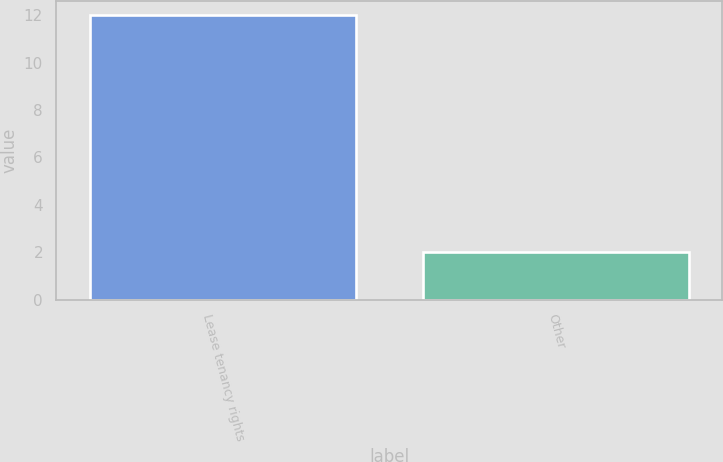Convert chart. <chart><loc_0><loc_0><loc_500><loc_500><bar_chart><fcel>Lease tenancy rights<fcel>Other<nl><fcel>12<fcel>2<nl></chart> 